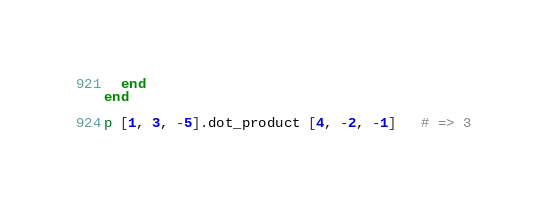Convert code to text. <code><loc_0><loc_0><loc_500><loc_500><_Ruby_>  end
end

p [1, 3, -5].dot_product [4, -2, -1]   # => 3
</code> 